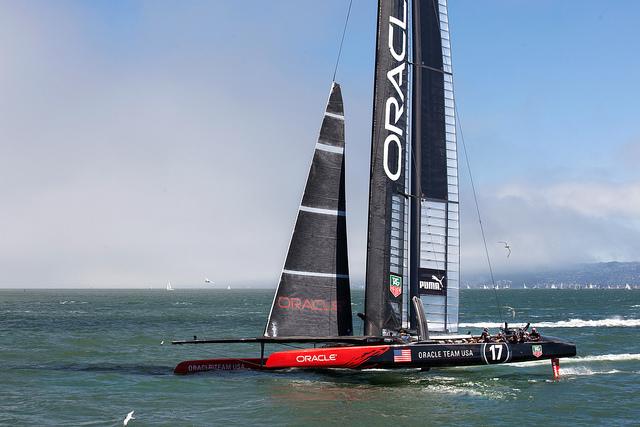Where is this?
Write a very short answer. Ocean. What is written on the sail?
Answer briefly. Oracle. What number is on the first boat?
Be succinct. 17. What kind of vehicle is shown?
Answer briefly. Boat. What is the advertising asking the reader to do?
Give a very brief answer. Oracle. What does the sail say?
Short answer required. Oracle. 